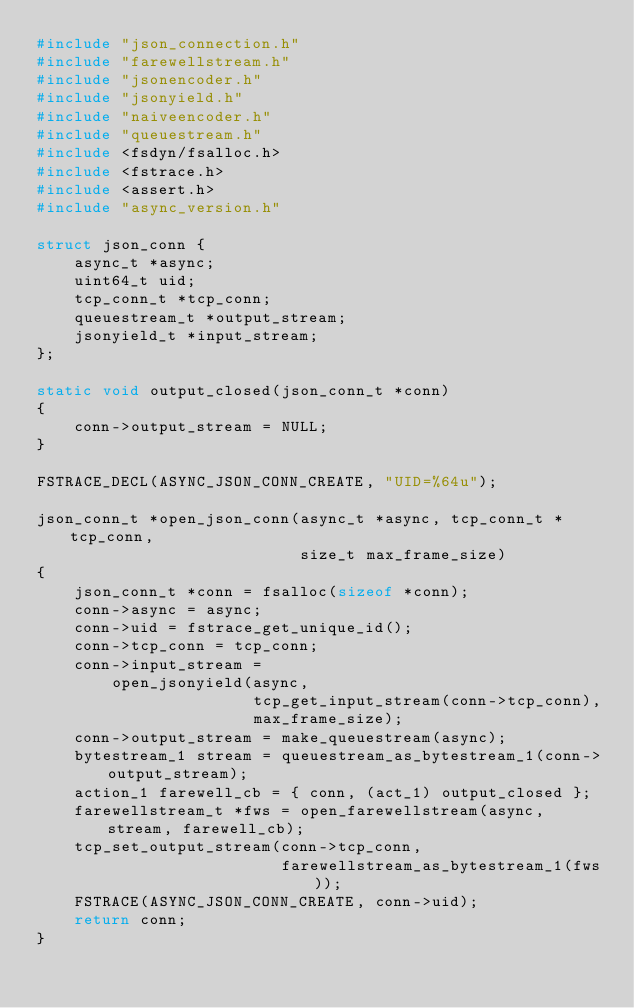Convert code to text. <code><loc_0><loc_0><loc_500><loc_500><_C_>#include "json_connection.h"
#include "farewellstream.h"
#include "jsonencoder.h"
#include "jsonyield.h"
#include "naiveencoder.h"
#include "queuestream.h"
#include <fsdyn/fsalloc.h>
#include <fstrace.h>
#include <assert.h>
#include "async_version.h"

struct json_conn {
    async_t *async;
    uint64_t uid;
    tcp_conn_t *tcp_conn;
    queuestream_t *output_stream;
    jsonyield_t *input_stream;
};

static void output_closed(json_conn_t *conn)
{
    conn->output_stream = NULL;
}

FSTRACE_DECL(ASYNC_JSON_CONN_CREATE, "UID=%64u");

json_conn_t *open_json_conn(async_t *async, tcp_conn_t *tcp_conn,
                            size_t max_frame_size)
{
    json_conn_t *conn = fsalloc(sizeof *conn);
    conn->async = async;
    conn->uid = fstrace_get_unique_id();
    conn->tcp_conn = tcp_conn;
    conn->input_stream =
        open_jsonyield(async,
                       tcp_get_input_stream(conn->tcp_conn),
                       max_frame_size);
    conn->output_stream = make_queuestream(async);
    bytestream_1 stream = queuestream_as_bytestream_1(conn->output_stream);
    action_1 farewell_cb = { conn, (act_1) output_closed };
    farewellstream_t *fws = open_farewellstream(async, stream, farewell_cb);
    tcp_set_output_stream(conn->tcp_conn,
                          farewellstream_as_bytestream_1(fws));
    FSTRACE(ASYNC_JSON_CONN_CREATE, conn->uid);
    return conn;
}
</code> 